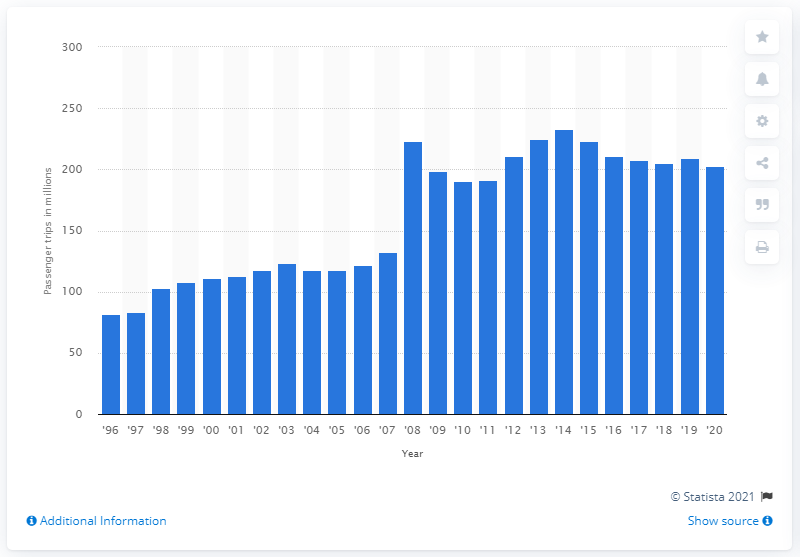List a handful of essential elements in this visual. In 2020, the total number of unlinked passenger trips in demand-responsive transport was 202,380. In 2020, there were a total of 202,380 unlinked passenger trips on demand-responsive transport. 